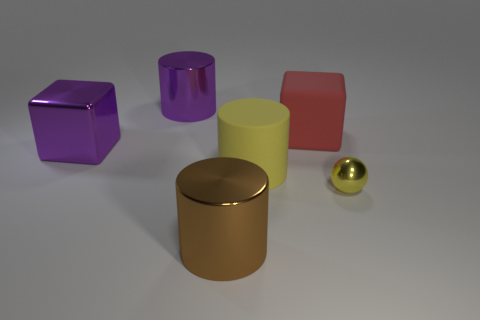What number of yellow objects have the same size as the red rubber cube?
Give a very brief answer. 1. Is the number of small yellow metal things that are behind the rubber cylinder less than the number of metallic objects?
Provide a short and direct response. Yes. There is a rubber thing on the left side of the block behind the large purple metallic block; how big is it?
Your response must be concise. Large. What number of things are either small yellow metal cylinders or cylinders?
Ensure brevity in your answer.  3. Is there a object that has the same color as the tiny sphere?
Provide a short and direct response. Yes. Is the number of big purple cylinders less than the number of large cyan metal balls?
Make the answer very short. No. What number of objects are either yellow cylinders or objects that are on the left side of the tiny yellow shiny object?
Ensure brevity in your answer.  5. Is there a big red cylinder that has the same material as the big red object?
Offer a very short reply. No. What material is the purple cylinder that is the same size as the matte cube?
Give a very brief answer. Metal. What is the thing that is in front of the metal thing that is on the right side of the brown thing made of?
Give a very brief answer. Metal. 